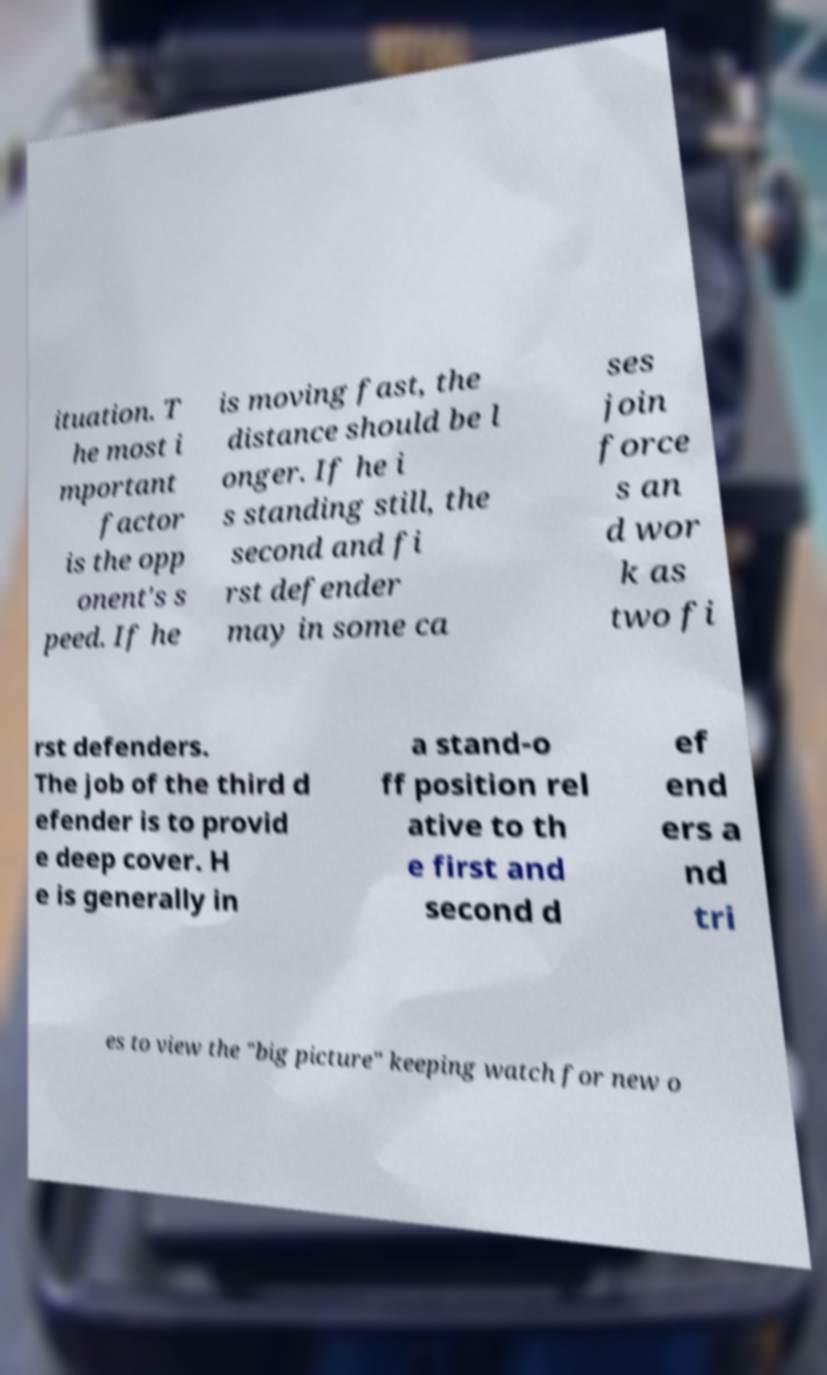Could you extract and type out the text from this image? ituation. T he most i mportant factor is the opp onent's s peed. If he is moving fast, the distance should be l onger. If he i s standing still, the second and fi rst defender may in some ca ses join force s an d wor k as two fi rst defenders. The job of the third d efender is to provid e deep cover. H e is generally in a stand-o ff position rel ative to th e first and second d ef end ers a nd tri es to view the "big picture" keeping watch for new o 